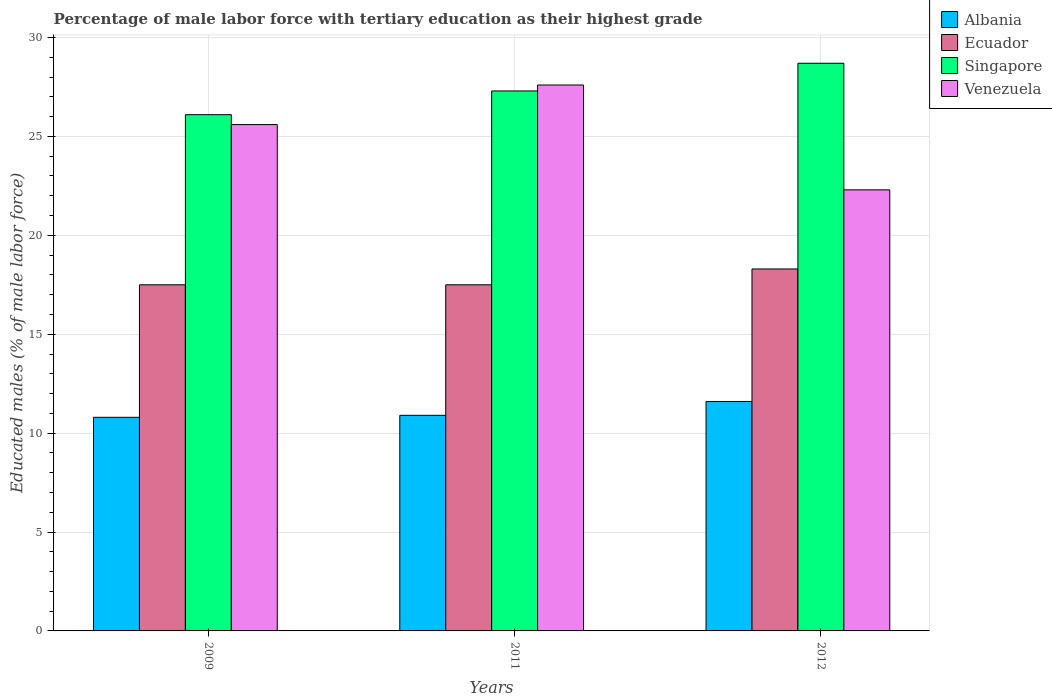Are the number of bars per tick equal to the number of legend labels?
Provide a short and direct response. Yes. How many bars are there on the 2nd tick from the left?
Provide a succinct answer. 4. How many bars are there on the 1st tick from the right?
Keep it short and to the point. 4. What is the percentage of male labor force with tertiary education in Singapore in 2012?
Give a very brief answer. 28.7. Across all years, what is the maximum percentage of male labor force with tertiary education in Albania?
Offer a terse response. 11.6. Across all years, what is the minimum percentage of male labor force with tertiary education in Singapore?
Provide a short and direct response. 26.1. In which year was the percentage of male labor force with tertiary education in Ecuador maximum?
Provide a succinct answer. 2012. In which year was the percentage of male labor force with tertiary education in Albania minimum?
Offer a very short reply. 2009. What is the total percentage of male labor force with tertiary education in Venezuela in the graph?
Make the answer very short. 75.5. What is the difference between the percentage of male labor force with tertiary education in Singapore in 2011 and that in 2012?
Offer a very short reply. -1.4. What is the difference between the percentage of male labor force with tertiary education in Singapore in 2011 and the percentage of male labor force with tertiary education in Venezuela in 2009?
Keep it short and to the point. 1.7. What is the average percentage of male labor force with tertiary education in Singapore per year?
Your answer should be very brief. 27.37. In the year 2011, what is the difference between the percentage of male labor force with tertiary education in Albania and percentage of male labor force with tertiary education in Venezuela?
Offer a very short reply. -16.7. What is the ratio of the percentage of male labor force with tertiary education in Singapore in 2009 to that in 2011?
Provide a short and direct response. 0.96. Is the difference between the percentage of male labor force with tertiary education in Albania in 2009 and 2011 greater than the difference between the percentage of male labor force with tertiary education in Venezuela in 2009 and 2011?
Your answer should be very brief. Yes. What is the difference between the highest and the second highest percentage of male labor force with tertiary education in Ecuador?
Provide a short and direct response. 0.8. What is the difference between the highest and the lowest percentage of male labor force with tertiary education in Singapore?
Your answer should be very brief. 2.6. In how many years, is the percentage of male labor force with tertiary education in Singapore greater than the average percentage of male labor force with tertiary education in Singapore taken over all years?
Make the answer very short. 1. Is the sum of the percentage of male labor force with tertiary education in Singapore in 2009 and 2012 greater than the maximum percentage of male labor force with tertiary education in Albania across all years?
Your answer should be very brief. Yes. What does the 4th bar from the left in 2012 represents?
Provide a short and direct response. Venezuela. What does the 1st bar from the right in 2012 represents?
Make the answer very short. Venezuela. Is it the case that in every year, the sum of the percentage of male labor force with tertiary education in Singapore and percentage of male labor force with tertiary education in Venezuela is greater than the percentage of male labor force with tertiary education in Ecuador?
Ensure brevity in your answer.  Yes. How many bars are there?
Ensure brevity in your answer.  12. Are all the bars in the graph horizontal?
Provide a short and direct response. No. How many years are there in the graph?
Offer a very short reply. 3. What is the difference between two consecutive major ticks on the Y-axis?
Offer a very short reply. 5. Are the values on the major ticks of Y-axis written in scientific E-notation?
Your answer should be compact. No. Does the graph contain any zero values?
Provide a succinct answer. No. Does the graph contain grids?
Provide a short and direct response. Yes. Where does the legend appear in the graph?
Offer a terse response. Top right. How many legend labels are there?
Provide a short and direct response. 4. What is the title of the graph?
Ensure brevity in your answer.  Percentage of male labor force with tertiary education as their highest grade. Does "Montenegro" appear as one of the legend labels in the graph?
Your answer should be compact. No. What is the label or title of the X-axis?
Your answer should be very brief. Years. What is the label or title of the Y-axis?
Provide a short and direct response. Educated males (% of male labor force). What is the Educated males (% of male labor force) of Albania in 2009?
Provide a short and direct response. 10.8. What is the Educated males (% of male labor force) of Ecuador in 2009?
Your response must be concise. 17.5. What is the Educated males (% of male labor force) in Singapore in 2009?
Your answer should be very brief. 26.1. What is the Educated males (% of male labor force) in Venezuela in 2009?
Offer a terse response. 25.6. What is the Educated males (% of male labor force) in Albania in 2011?
Your response must be concise. 10.9. What is the Educated males (% of male labor force) of Singapore in 2011?
Make the answer very short. 27.3. What is the Educated males (% of male labor force) of Venezuela in 2011?
Make the answer very short. 27.6. What is the Educated males (% of male labor force) of Albania in 2012?
Make the answer very short. 11.6. What is the Educated males (% of male labor force) in Ecuador in 2012?
Ensure brevity in your answer.  18.3. What is the Educated males (% of male labor force) of Singapore in 2012?
Provide a succinct answer. 28.7. What is the Educated males (% of male labor force) in Venezuela in 2012?
Provide a short and direct response. 22.3. Across all years, what is the maximum Educated males (% of male labor force) in Albania?
Keep it short and to the point. 11.6. Across all years, what is the maximum Educated males (% of male labor force) of Ecuador?
Ensure brevity in your answer.  18.3. Across all years, what is the maximum Educated males (% of male labor force) of Singapore?
Give a very brief answer. 28.7. Across all years, what is the maximum Educated males (% of male labor force) of Venezuela?
Your answer should be compact. 27.6. Across all years, what is the minimum Educated males (% of male labor force) in Albania?
Your answer should be very brief. 10.8. Across all years, what is the minimum Educated males (% of male labor force) of Ecuador?
Your answer should be compact. 17.5. Across all years, what is the minimum Educated males (% of male labor force) of Singapore?
Offer a very short reply. 26.1. Across all years, what is the minimum Educated males (% of male labor force) of Venezuela?
Make the answer very short. 22.3. What is the total Educated males (% of male labor force) in Albania in the graph?
Your answer should be compact. 33.3. What is the total Educated males (% of male labor force) in Ecuador in the graph?
Give a very brief answer. 53.3. What is the total Educated males (% of male labor force) of Singapore in the graph?
Offer a terse response. 82.1. What is the total Educated males (% of male labor force) in Venezuela in the graph?
Ensure brevity in your answer.  75.5. What is the difference between the Educated males (% of male labor force) of Ecuador in 2009 and that in 2011?
Make the answer very short. 0. What is the difference between the Educated males (% of male labor force) of Singapore in 2009 and that in 2011?
Provide a succinct answer. -1.2. What is the difference between the Educated males (% of male labor force) of Venezuela in 2009 and that in 2011?
Keep it short and to the point. -2. What is the difference between the Educated males (% of male labor force) of Ecuador in 2009 and that in 2012?
Offer a terse response. -0.8. What is the difference between the Educated males (% of male labor force) of Singapore in 2009 and that in 2012?
Offer a very short reply. -2.6. What is the difference between the Educated males (% of male labor force) in Albania in 2011 and that in 2012?
Your answer should be very brief. -0.7. What is the difference between the Educated males (% of male labor force) of Ecuador in 2011 and that in 2012?
Offer a very short reply. -0.8. What is the difference between the Educated males (% of male labor force) in Albania in 2009 and the Educated males (% of male labor force) in Singapore in 2011?
Your response must be concise. -16.5. What is the difference between the Educated males (% of male labor force) of Albania in 2009 and the Educated males (% of male labor force) of Venezuela in 2011?
Make the answer very short. -16.8. What is the difference between the Educated males (% of male labor force) of Ecuador in 2009 and the Educated males (% of male labor force) of Singapore in 2011?
Provide a succinct answer. -9.8. What is the difference between the Educated males (% of male labor force) of Ecuador in 2009 and the Educated males (% of male labor force) of Venezuela in 2011?
Make the answer very short. -10.1. What is the difference between the Educated males (% of male labor force) in Singapore in 2009 and the Educated males (% of male labor force) in Venezuela in 2011?
Your answer should be very brief. -1.5. What is the difference between the Educated males (% of male labor force) of Albania in 2009 and the Educated males (% of male labor force) of Singapore in 2012?
Offer a terse response. -17.9. What is the difference between the Educated males (% of male labor force) in Ecuador in 2009 and the Educated males (% of male labor force) in Venezuela in 2012?
Give a very brief answer. -4.8. What is the difference between the Educated males (% of male labor force) of Singapore in 2009 and the Educated males (% of male labor force) of Venezuela in 2012?
Keep it short and to the point. 3.8. What is the difference between the Educated males (% of male labor force) of Albania in 2011 and the Educated males (% of male labor force) of Singapore in 2012?
Make the answer very short. -17.8. What is the average Educated males (% of male labor force) of Ecuador per year?
Give a very brief answer. 17.77. What is the average Educated males (% of male labor force) in Singapore per year?
Provide a succinct answer. 27.37. What is the average Educated males (% of male labor force) of Venezuela per year?
Give a very brief answer. 25.17. In the year 2009, what is the difference between the Educated males (% of male labor force) of Albania and Educated males (% of male labor force) of Singapore?
Offer a very short reply. -15.3. In the year 2009, what is the difference between the Educated males (% of male labor force) of Albania and Educated males (% of male labor force) of Venezuela?
Ensure brevity in your answer.  -14.8. In the year 2009, what is the difference between the Educated males (% of male labor force) in Ecuador and Educated males (% of male labor force) in Venezuela?
Offer a terse response. -8.1. In the year 2011, what is the difference between the Educated males (% of male labor force) in Albania and Educated males (% of male labor force) in Singapore?
Give a very brief answer. -16.4. In the year 2011, what is the difference between the Educated males (% of male labor force) in Albania and Educated males (% of male labor force) in Venezuela?
Make the answer very short. -16.7. In the year 2011, what is the difference between the Educated males (% of male labor force) of Ecuador and Educated males (% of male labor force) of Singapore?
Offer a terse response. -9.8. In the year 2011, what is the difference between the Educated males (% of male labor force) in Singapore and Educated males (% of male labor force) in Venezuela?
Ensure brevity in your answer.  -0.3. In the year 2012, what is the difference between the Educated males (% of male labor force) of Albania and Educated males (% of male labor force) of Singapore?
Provide a succinct answer. -17.1. In the year 2012, what is the difference between the Educated males (% of male labor force) in Albania and Educated males (% of male labor force) in Venezuela?
Keep it short and to the point. -10.7. What is the ratio of the Educated males (% of male labor force) in Singapore in 2009 to that in 2011?
Offer a terse response. 0.96. What is the ratio of the Educated males (% of male labor force) in Venezuela in 2009 to that in 2011?
Offer a terse response. 0.93. What is the ratio of the Educated males (% of male labor force) of Ecuador in 2009 to that in 2012?
Ensure brevity in your answer.  0.96. What is the ratio of the Educated males (% of male labor force) in Singapore in 2009 to that in 2012?
Give a very brief answer. 0.91. What is the ratio of the Educated males (% of male labor force) in Venezuela in 2009 to that in 2012?
Offer a terse response. 1.15. What is the ratio of the Educated males (% of male labor force) of Albania in 2011 to that in 2012?
Keep it short and to the point. 0.94. What is the ratio of the Educated males (% of male labor force) of Ecuador in 2011 to that in 2012?
Keep it short and to the point. 0.96. What is the ratio of the Educated males (% of male labor force) of Singapore in 2011 to that in 2012?
Your response must be concise. 0.95. What is the ratio of the Educated males (% of male labor force) in Venezuela in 2011 to that in 2012?
Provide a succinct answer. 1.24. What is the difference between the highest and the second highest Educated males (% of male labor force) of Albania?
Give a very brief answer. 0.7. What is the difference between the highest and the second highest Educated males (% of male labor force) in Ecuador?
Provide a short and direct response. 0.8. What is the difference between the highest and the second highest Educated males (% of male labor force) of Singapore?
Offer a terse response. 1.4. What is the difference between the highest and the second highest Educated males (% of male labor force) in Venezuela?
Offer a very short reply. 2. What is the difference between the highest and the lowest Educated males (% of male labor force) in Albania?
Keep it short and to the point. 0.8. What is the difference between the highest and the lowest Educated males (% of male labor force) of Ecuador?
Keep it short and to the point. 0.8. What is the difference between the highest and the lowest Educated males (% of male labor force) of Singapore?
Provide a short and direct response. 2.6. What is the difference between the highest and the lowest Educated males (% of male labor force) in Venezuela?
Provide a succinct answer. 5.3. 